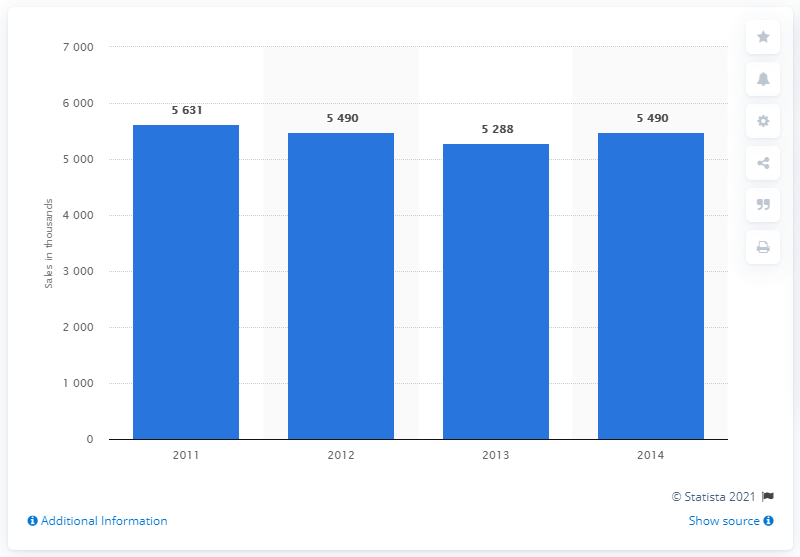Give some essential details in this illustration. In 2014, it is projected that almost 5.5 million desktop PCs will be sold in Japan. 